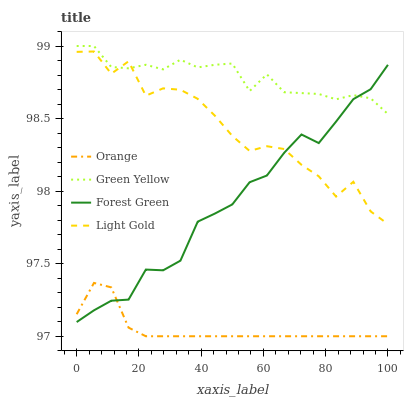Does Orange have the minimum area under the curve?
Answer yes or no. Yes. Does Green Yellow have the maximum area under the curve?
Answer yes or no. Yes. Does Forest Green have the minimum area under the curve?
Answer yes or no. No. Does Forest Green have the maximum area under the curve?
Answer yes or no. No. Is Orange the smoothest?
Answer yes or no. Yes. Is Light Gold the roughest?
Answer yes or no. Yes. Is Forest Green the smoothest?
Answer yes or no. No. Is Forest Green the roughest?
Answer yes or no. No. Does Forest Green have the lowest value?
Answer yes or no. No. Does Green Yellow have the highest value?
Answer yes or no. Yes. Does Forest Green have the highest value?
Answer yes or no. No. Is Orange less than Green Yellow?
Answer yes or no. Yes. Is Light Gold greater than Orange?
Answer yes or no. Yes. Does Forest Green intersect Light Gold?
Answer yes or no. Yes. Is Forest Green less than Light Gold?
Answer yes or no. No. Is Forest Green greater than Light Gold?
Answer yes or no. No. Does Orange intersect Green Yellow?
Answer yes or no. No. 